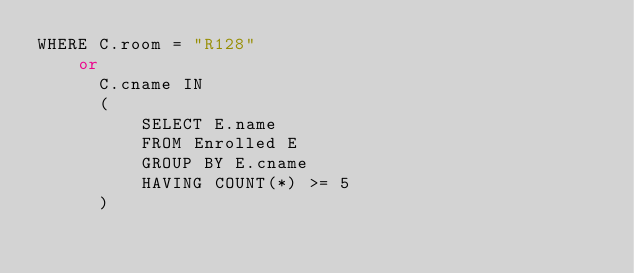<code> <loc_0><loc_0><loc_500><loc_500><_SQL_>WHERE C.room = "R128" 
    or 
      C.cname IN 
      (
          SELECT E.name
          FROM Enrolled E
          GROUP BY E.cname
          HAVING COUNT(*) >= 5
      )
</code> 